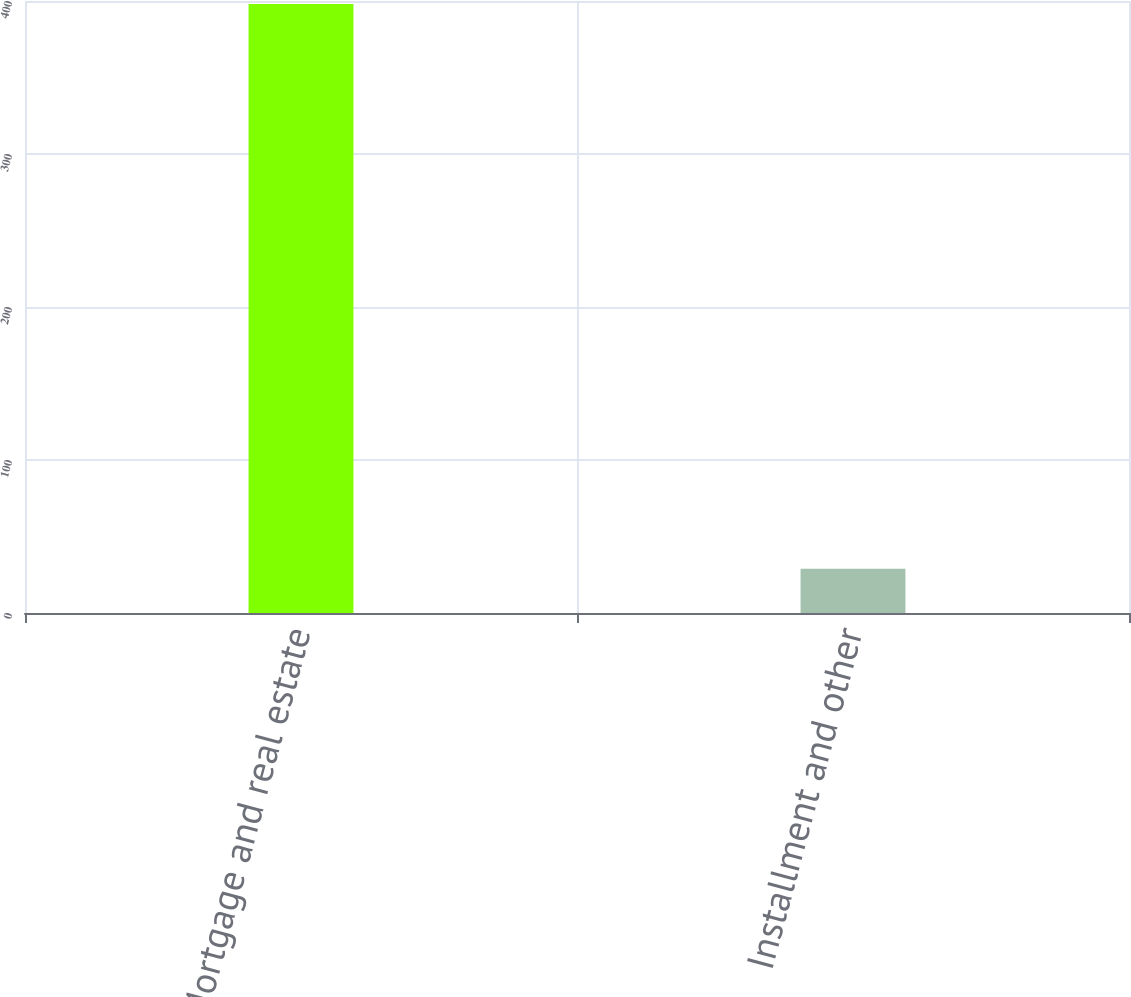<chart> <loc_0><loc_0><loc_500><loc_500><bar_chart><fcel>Mortgage and real estate<fcel>Installment and other<nl><fcel>398<fcel>29<nl></chart> 